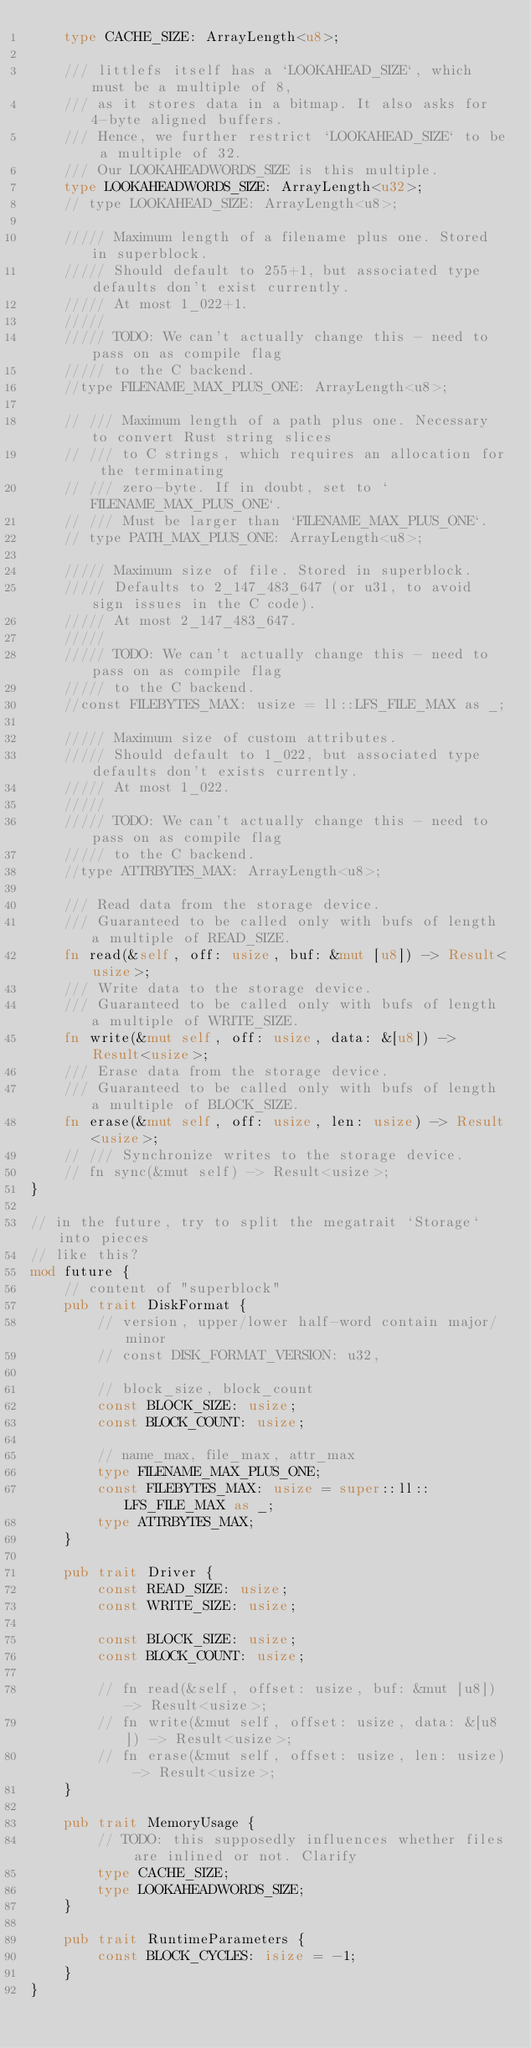<code> <loc_0><loc_0><loc_500><loc_500><_Rust_>    type CACHE_SIZE: ArrayLength<u8>;

    /// littlefs itself has a `LOOKAHEAD_SIZE`, which must be a multiple of 8,
    /// as it stores data in a bitmap. It also asks for 4-byte aligned buffers.
    /// Hence, we further restrict `LOOKAHEAD_SIZE` to be a multiple of 32.
    /// Our LOOKAHEADWORDS_SIZE is this multiple.
    type LOOKAHEADWORDS_SIZE: ArrayLength<u32>;
    // type LOOKAHEAD_SIZE: ArrayLength<u8>;

    ///// Maximum length of a filename plus one. Stored in superblock.
    ///// Should default to 255+1, but associated type defaults don't exist currently.
    ///// At most 1_022+1.
    /////
    ///// TODO: We can't actually change this - need to pass on as compile flag
    ///// to the C backend.
    //type FILENAME_MAX_PLUS_ONE: ArrayLength<u8>;

    // /// Maximum length of a path plus one. Necessary to convert Rust string slices
    // /// to C strings, which requires an allocation for the terminating
    // /// zero-byte. If in doubt, set to `FILENAME_MAX_PLUS_ONE`.
    // /// Must be larger than `FILENAME_MAX_PLUS_ONE`.
    // type PATH_MAX_PLUS_ONE: ArrayLength<u8>;

    ///// Maximum size of file. Stored in superblock.
    ///// Defaults to 2_147_483_647 (or u31, to avoid sign issues in the C code).
    ///// At most 2_147_483_647.
    /////
    ///// TODO: We can't actually change this - need to pass on as compile flag
    ///// to the C backend.
    //const FILEBYTES_MAX: usize = ll::LFS_FILE_MAX as _;

    ///// Maximum size of custom attributes.
    ///// Should default to 1_022, but associated type defaults don't exists currently.
    ///// At most 1_022.
    /////
    ///// TODO: We can't actually change this - need to pass on as compile flag
    ///// to the C backend.
    //type ATTRBYTES_MAX: ArrayLength<u8>;

    /// Read data from the storage device.
    /// Guaranteed to be called only with bufs of length a multiple of READ_SIZE.
    fn read(&self, off: usize, buf: &mut [u8]) -> Result<usize>;
    /// Write data to the storage device.
    /// Guaranteed to be called only with bufs of length a multiple of WRITE_SIZE.
    fn write(&mut self, off: usize, data: &[u8]) -> Result<usize>;
    /// Erase data from the storage device.
    /// Guaranteed to be called only with bufs of length a multiple of BLOCK_SIZE.
    fn erase(&mut self, off: usize, len: usize) -> Result<usize>;
    // /// Synchronize writes to the storage device.
    // fn sync(&mut self) -> Result<usize>;
}

// in the future, try to split the megatrait `Storage` into pieces
// like this?
mod future {
    // content of "superblock"
    pub trait DiskFormat {
        // version, upper/lower half-word contain major/minor
        // const DISK_FORMAT_VERSION: u32,

        // block_size, block_count
        const BLOCK_SIZE: usize;
        const BLOCK_COUNT: usize;

        // name_max, file_max, attr_max
        type FILENAME_MAX_PLUS_ONE;
        const FILEBYTES_MAX: usize = super::ll::LFS_FILE_MAX as _;
        type ATTRBYTES_MAX;
    }

    pub trait Driver {
        const READ_SIZE: usize;
        const WRITE_SIZE: usize;

        const BLOCK_SIZE: usize;
        const BLOCK_COUNT: usize;

        // fn read(&self, offset: usize, buf: &mut [u8]) -> Result<usize>;
        // fn write(&mut self, offset: usize, data: &[u8]) -> Result<usize>;
        // fn erase(&mut self, offset: usize, len: usize) -> Result<usize>;
    }

    pub trait MemoryUsage {
        // TODO: this supposedly influences whether files are inlined or not. Clarify
        type CACHE_SIZE;
        type LOOKAHEADWORDS_SIZE;
    }

    pub trait RuntimeParameters {
        const BLOCK_CYCLES: isize = -1;
    }
}
</code> 